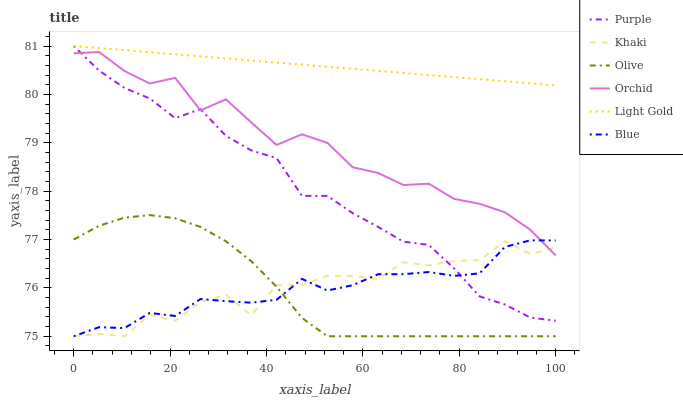Does Olive have the minimum area under the curve?
Answer yes or no. Yes. Does Light Gold have the maximum area under the curve?
Answer yes or no. Yes. Does Khaki have the minimum area under the curve?
Answer yes or no. No. Does Khaki have the maximum area under the curve?
Answer yes or no. No. Is Light Gold the smoothest?
Answer yes or no. Yes. Is Khaki the roughest?
Answer yes or no. Yes. Is Purple the smoothest?
Answer yes or no. No. Is Purple the roughest?
Answer yes or no. No. Does Blue have the lowest value?
Answer yes or no. Yes. Does Purple have the lowest value?
Answer yes or no. No. Does Light Gold have the highest value?
Answer yes or no. Yes. Does Khaki have the highest value?
Answer yes or no. No. Is Khaki less than Light Gold?
Answer yes or no. Yes. Is Light Gold greater than Olive?
Answer yes or no. Yes. Does Khaki intersect Blue?
Answer yes or no. Yes. Is Khaki less than Blue?
Answer yes or no. No. Is Khaki greater than Blue?
Answer yes or no. No. Does Khaki intersect Light Gold?
Answer yes or no. No. 